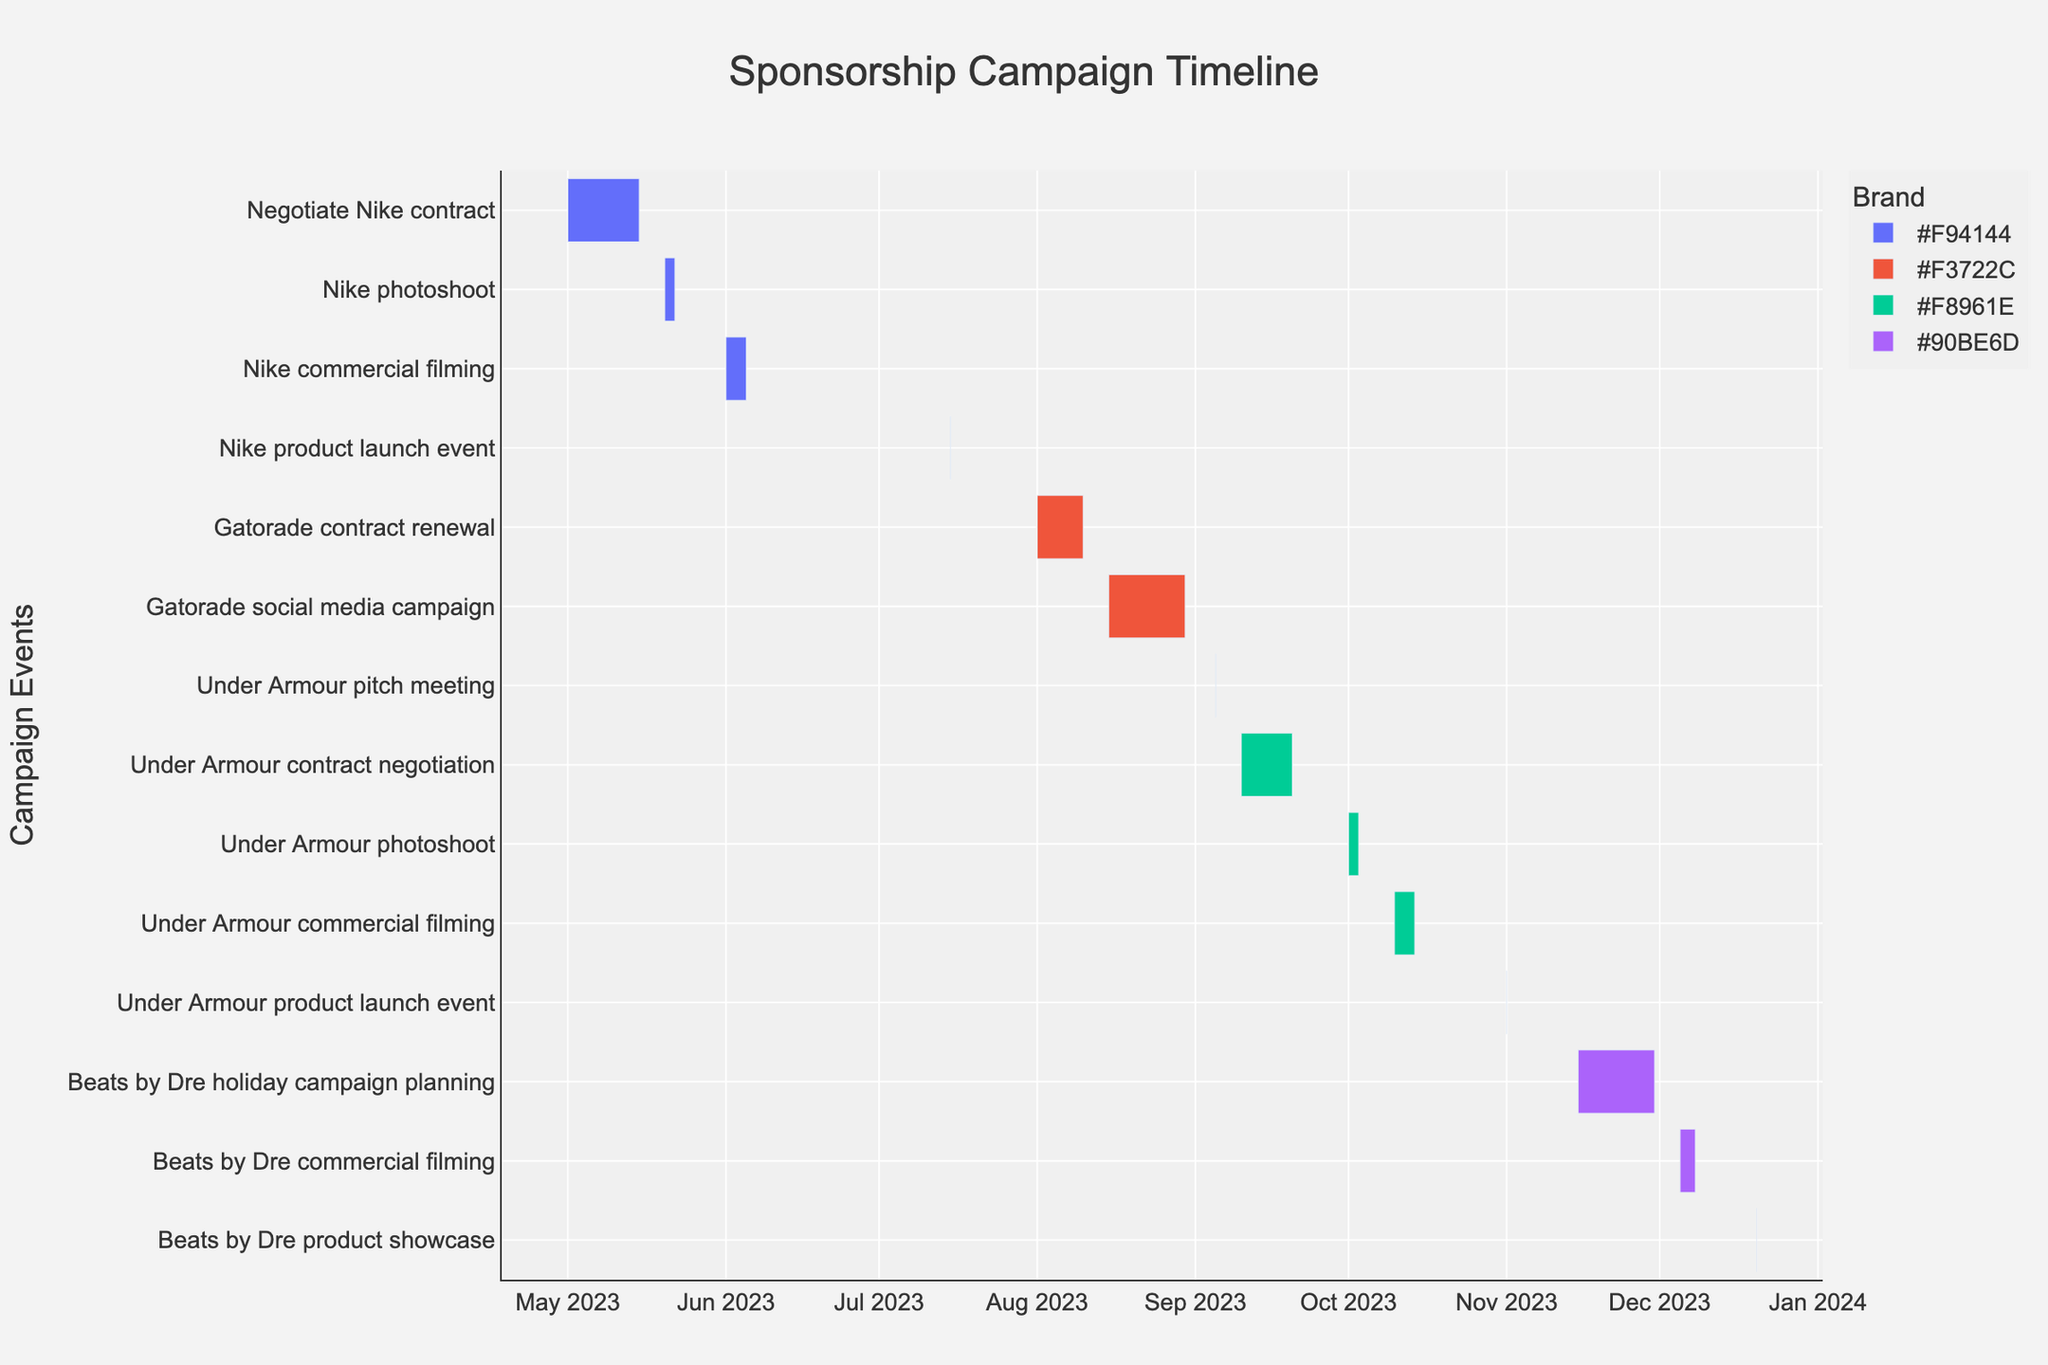What is the title of the Gantt Chart? The title is generally located at the top of the figure and provides insight into the focus of the chart. In this case, it represents the overall activity the chart is describing.
Answer: Sponsorship Campaign Timeline How many total tasks are shown in the Gantt Chart? To find the number of tasks, count all the unique task entries listed on the y-axis of the Gantt Chart.
Answer: 13 Which task was the shortest in duration? Look for the task with the smallest duration in terms of the bar length on the chart. It's important to identify the start and end dates for precise calculation.
Answer: Under Armour pitch meeting (1 day) What is the duration of the "Nike commercial filming" task? To find this, look for the start and end dates of this task and calculate the number of days in between, inclusive of both start and end dates.
Answer: 5 days Which brand has the most number of activities? Count the number of tasks associated with each brand. Determine which brand has the highest count
Answer: Under Armour (4 tasks) Which event spans from May 1 to May 15, 2023, and what is the general activity involved? Identify the bar that starts on May 1 and ends on May 15 and read the task label associated with it.
Answer: Negotiate Nike contract When does the "Gatorade social media campaign" start and end? Refer to the Gantt Chart and locate the bar for this specific task, then note the start and end dates.
Answer: Start: August 15, End: August 30, 2023 How much time is there between the end of "Nike product launch event" and the start of "Gatorade contract renewal"? Calculate the difference in days between the end date of the Nike event and the start date of the Gatorade task.
Answer: 17 days Which task immediately follows "Under Armour photoshoot"? Look at the order of events on the Gantt Chart to find which task starts right after the end of "Under Armour photoshoot".
Answer: Under Armour commercial filming How does the duration of "Beats by Dre commercial filming" compare to "Under Armour commercial filming"? Calculate the duration of both tasks by noting their start and end dates, and compare their lengths.
Answer: Beats by Dre: 4 days, Under Armour: 5 days 